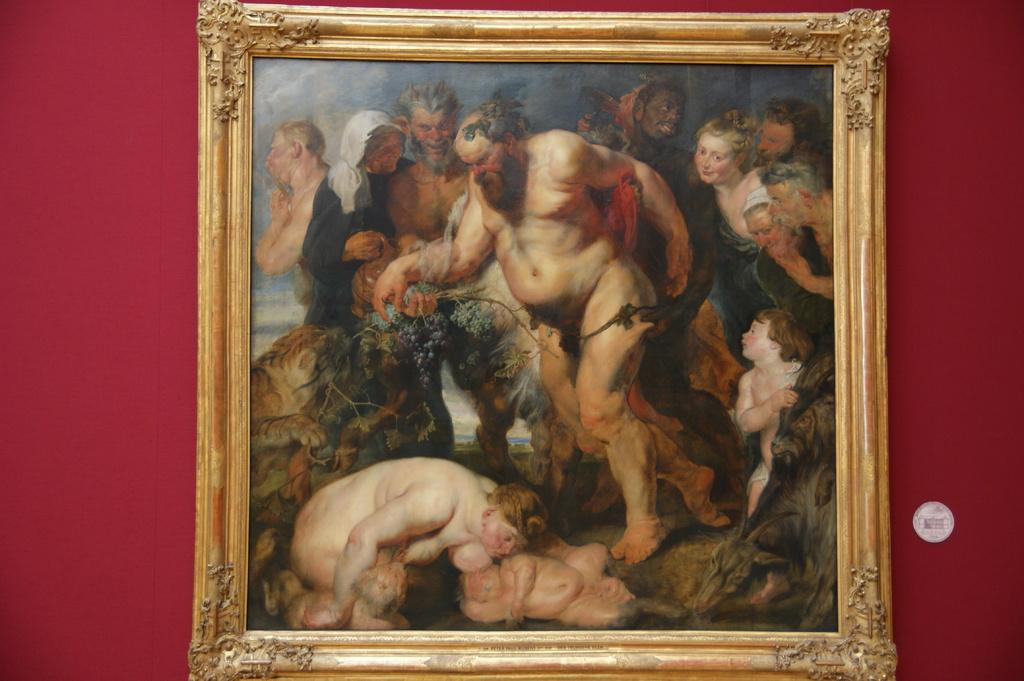What is the main subject of the image? There is a painting in the image. Where is the painting located? The painting is placed on a wall. What color is the object in the image? There is a white color object in the image. What can be seen in the painting? The painting contains images of many people. Can you tell me how many laborers are working on the coast in the image? There is no coast or laborers present in the image; it features a painting with images of many people. What type of paint is used to create the painting in the image? The type of paint used to create the painting is not visible or mentioned in the image. 